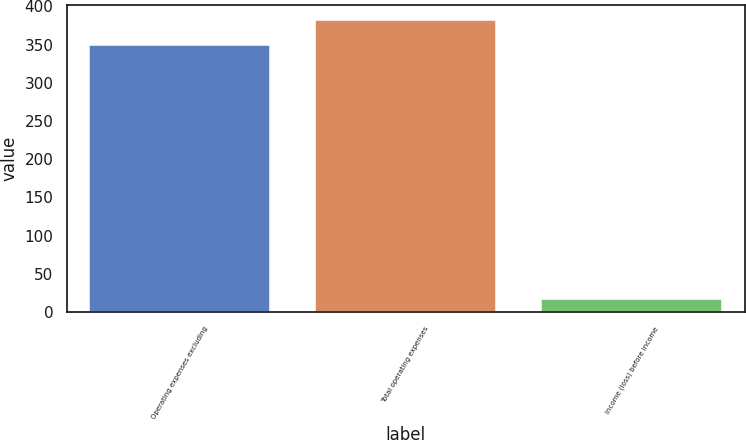Convert chart to OTSL. <chart><loc_0><loc_0><loc_500><loc_500><bar_chart><fcel>Operating expenses excluding<fcel>Total operating expenses<fcel>Income (loss) before income<nl><fcel>349<fcel>382.2<fcel>17<nl></chart> 